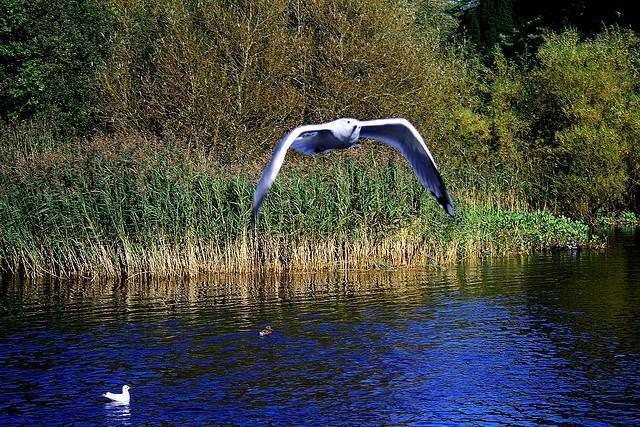How many animals are there?
Give a very brief answer. 3. How many people are in this picture?
Give a very brief answer. 0. 